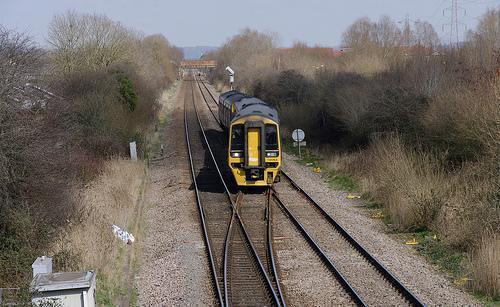How many trains are on the track?
Give a very brief answer. 1. 